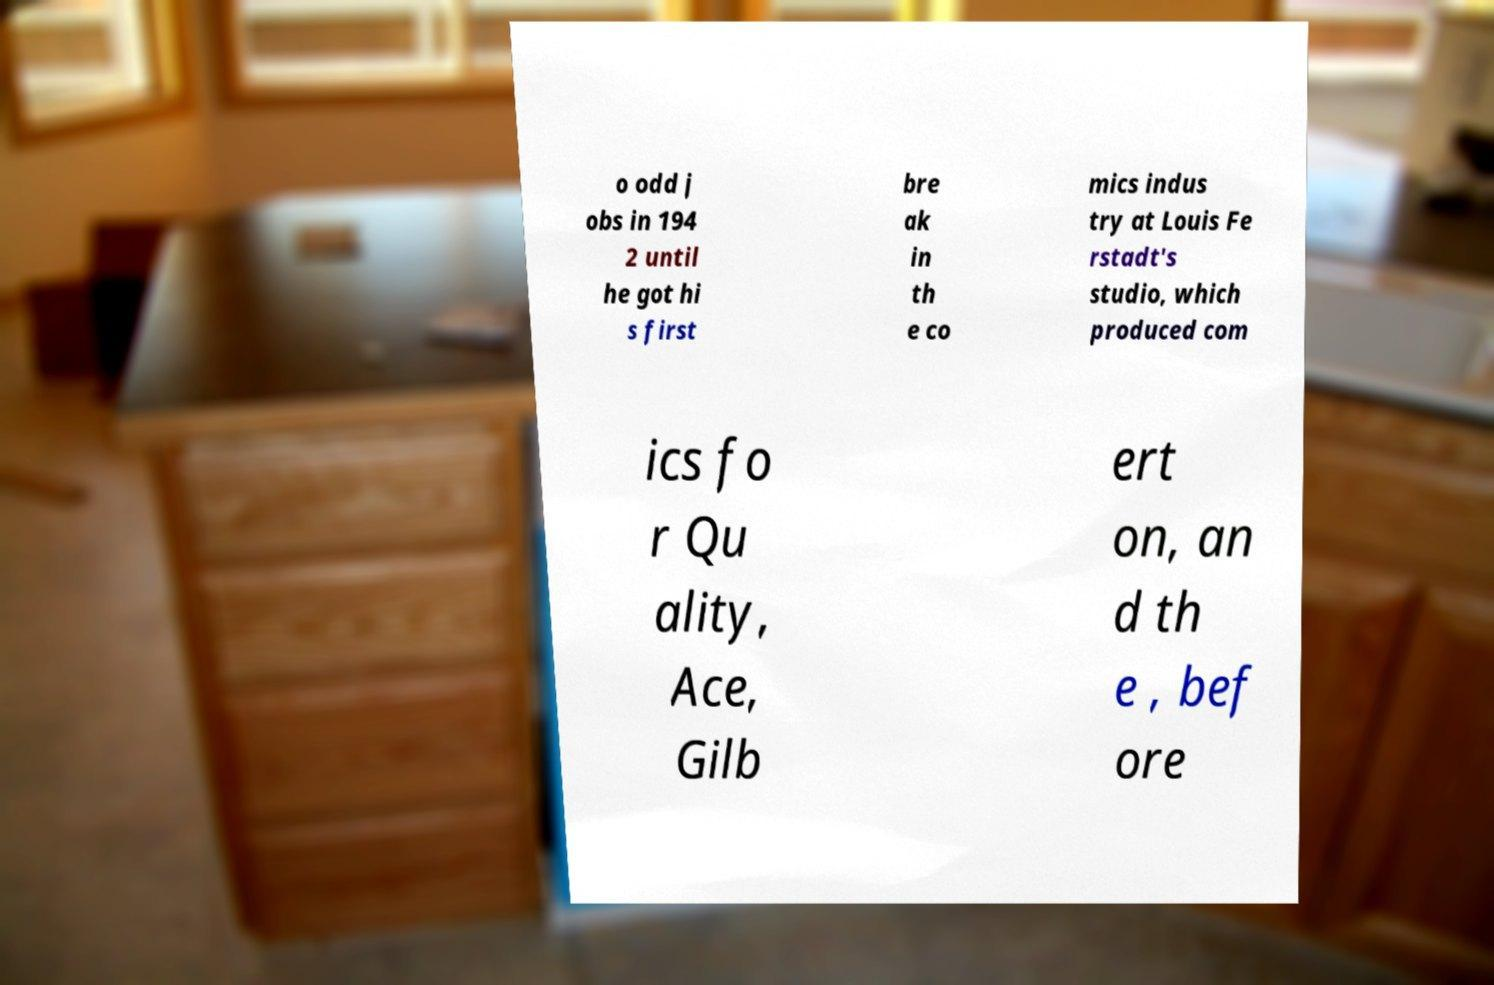Please read and relay the text visible in this image. What does it say? o odd j obs in 194 2 until he got hi s first bre ak in th e co mics indus try at Louis Fe rstadt's studio, which produced com ics fo r Qu ality, Ace, Gilb ert on, an d th e , bef ore 